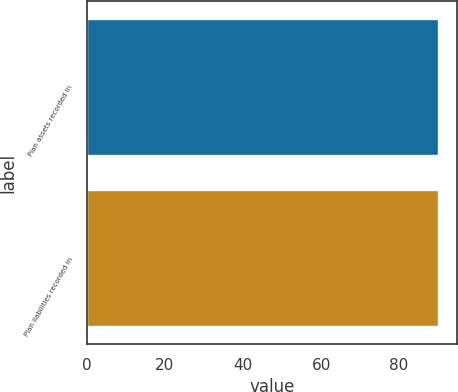<chart> <loc_0><loc_0><loc_500><loc_500><bar_chart><fcel>Plan assets recorded in<fcel>Plan liabilities recorded in<nl><fcel>90.1<fcel>90.2<nl></chart> 